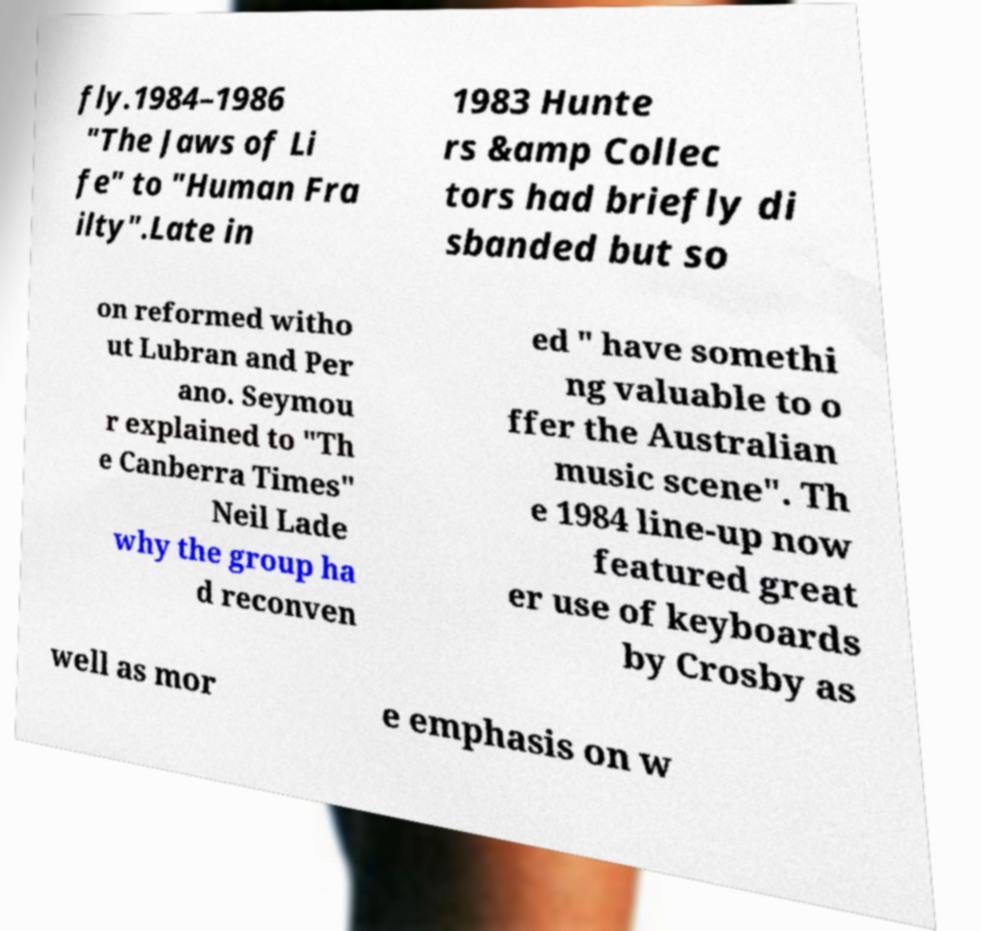Please read and relay the text visible in this image. What does it say? fly.1984–1986 "The Jaws of Li fe" to "Human Fra ilty".Late in 1983 Hunte rs &amp Collec tors had briefly di sbanded but so on reformed witho ut Lubran and Per ano. Seymou r explained to "Th e Canberra Times" Neil Lade why the group ha d reconven ed " have somethi ng valuable to o ffer the Australian music scene". Th e 1984 line-up now featured great er use of keyboards by Crosby as well as mor e emphasis on w 